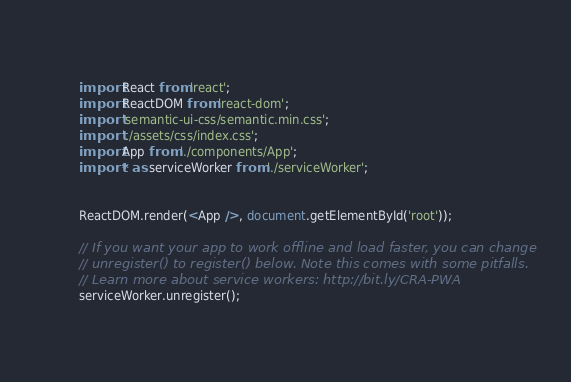<code> <loc_0><loc_0><loc_500><loc_500><_JavaScript_>import React from 'react';
import ReactDOM from 'react-dom';
import 'semantic-ui-css/semantic.min.css';
import './assets/css/index.css';
import App from './components/App';
import * as serviceWorker from './serviceWorker';


ReactDOM.render(<App />, document.getElementById('root'));

// If you want your app to work offline and load faster, you can change
// unregister() to register() below. Note this comes with some pitfalls.
// Learn more about service workers: http://bit.ly/CRA-PWA
serviceWorker.unregister();</code> 